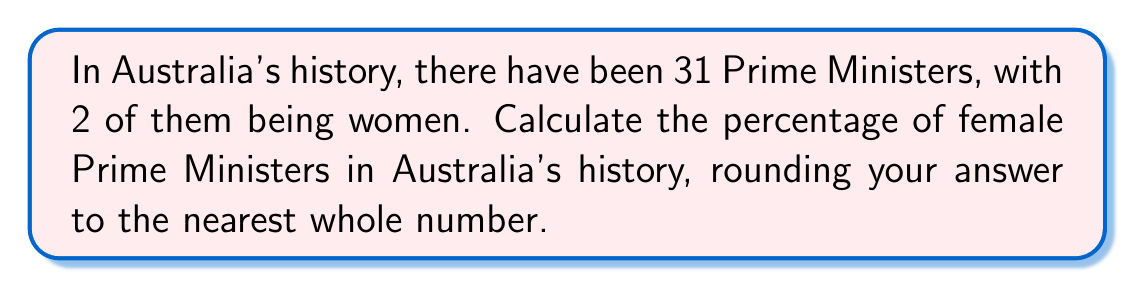Provide a solution to this math problem. To calculate the percentage of female Prime Ministers in Australia's history, we need to follow these steps:

1. Identify the total number of Prime Ministers:
   Total Prime Ministers = 31

2. Identify the number of female Prime Ministers:
   Female Prime Ministers = 2

3. Calculate the percentage using the formula:
   $$ \text{Percentage} = \frac{\text{Number of female Prime Ministers}}{\text{Total number of Prime Ministers}} \times 100\% $$

4. Plug in the values:
   $$ \text{Percentage} = \frac{2}{31} \times 100\% $$

5. Perform the calculation:
   $$ \text{Percentage} = 0.064516129 \times 100\% = 6.4516129\% $$

6. Round to the nearest whole number:
   6.4516129% rounds to 6%

Therefore, the percentage of female Prime Ministers in Australia's history, rounded to the nearest whole number, is 6%.
Answer: 6% 